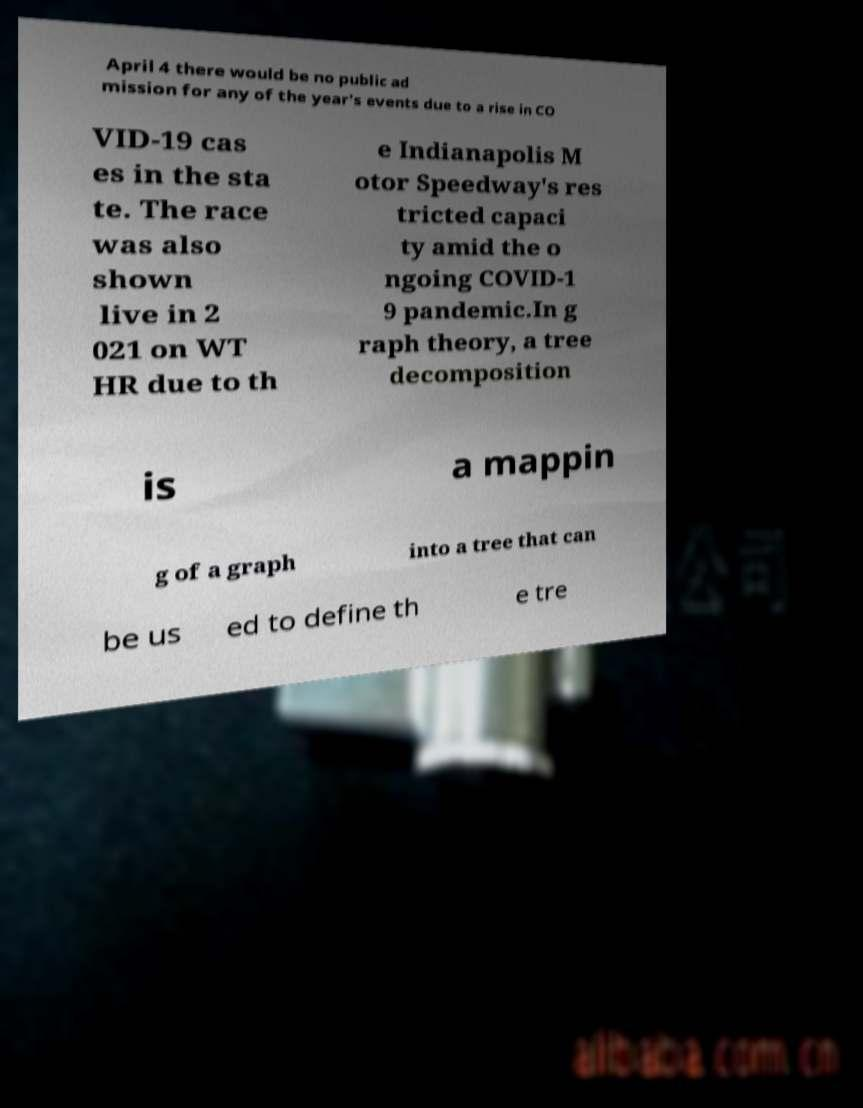Can you read and provide the text displayed in the image?This photo seems to have some interesting text. Can you extract and type it out for me? April 4 there would be no public ad mission for any of the year's events due to a rise in CO VID-19 cas es in the sta te. The race was also shown live in 2 021 on WT HR due to th e Indianapolis M otor Speedway's res tricted capaci ty amid the o ngoing COVID-1 9 pandemic.In g raph theory, a tree decomposition is a mappin g of a graph into a tree that can be us ed to define th e tre 